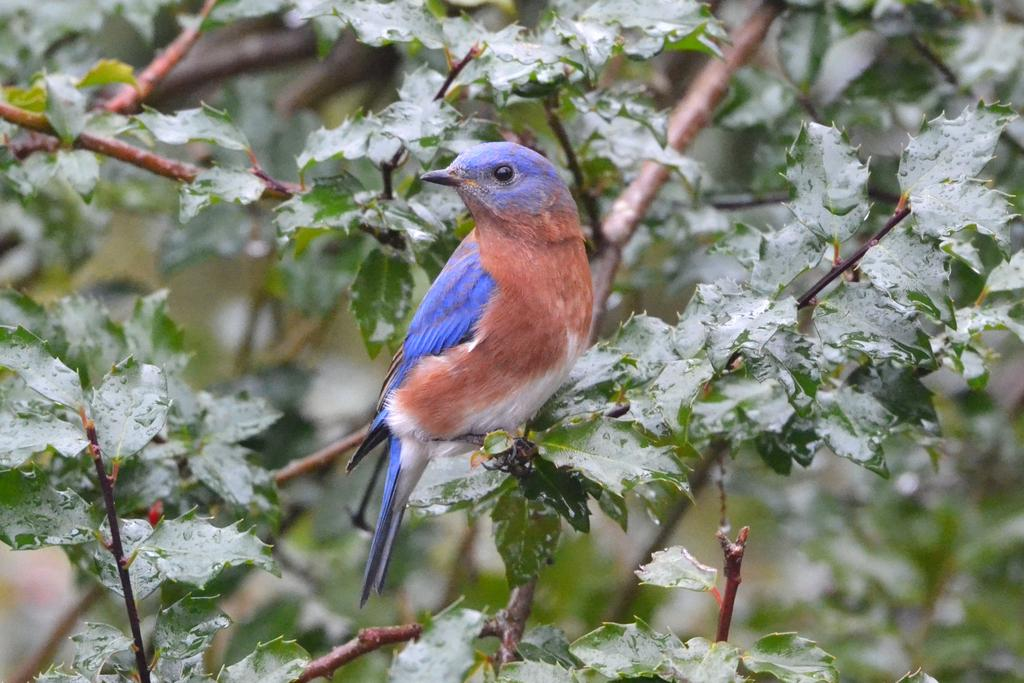What type of animal is in the image? There is a bird in the image. Where is the bird located? The bird is on a tree branch. What colors can be seen on the bird? The bird has blue, brown, and white coloring. What can be observed on the leaves in the image? There are water droplets on the leaves in the image. Are there any flowers growing on the island in the image? There is no island present in the image, and therefore no flowers growing on it. 